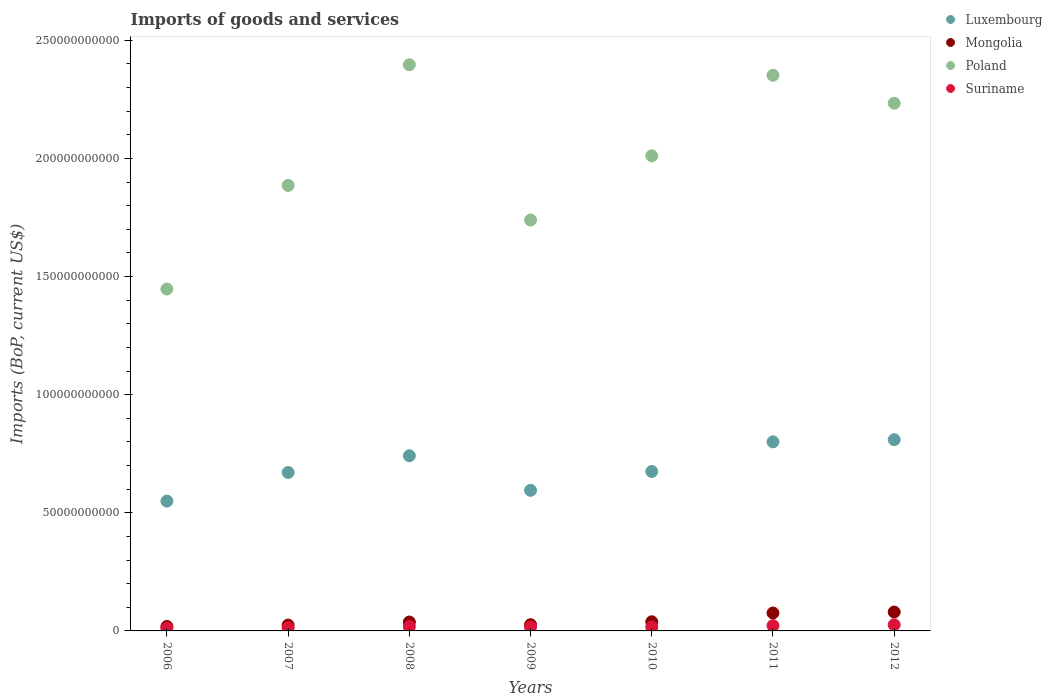What is the amount spent on imports in Suriname in 2008?
Your answer should be compact. 1.81e+09. Across all years, what is the maximum amount spent on imports in Mongolia?
Provide a succinct answer. 8.00e+09. Across all years, what is the minimum amount spent on imports in Mongolia?
Provide a succinct answer. 1.88e+09. In which year was the amount spent on imports in Suriname minimum?
Provide a short and direct response. 2006. What is the total amount spent on imports in Suriname in the graph?
Ensure brevity in your answer.  1.25e+1. What is the difference between the amount spent on imports in Poland in 2007 and that in 2010?
Provide a succinct answer. -1.25e+1. What is the difference between the amount spent on imports in Luxembourg in 2006 and the amount spent on imports in Suriname in 2012?
Provide a succinct answer. 5.24e+1. What is the average amount spent on imports in Poland per year?
Offer a very short reply. 2.01e+11. In the year 2007, what is the difference between the amount spent on imports in Suriname and amount spent on imports in Mongolia?
Your answer should be very brief. -1.11e+09. What is the ratio of the amount spent on imports in Suriname in 2007 to that in 2011?
Give a very brief answer. 0.61. What is the difference between the highest and the second highest amount spent on imports in Suriname?
Provide a short and direct response. 3.42e+08. What is the difference between the highest and the lowest amount spent on imports in Suriname?
Provide a succinct answer. 1.41e+09. Does the amount spent on imports in Suriname monotonically increase over the years?
Provide a succinct answer. No. How many dotlines are there?
Make the answer very short. 4. What is the difference between two consecutive major ticks on the Y-axis?
Ensure brevity in your answer.  5.00e+1. Are the values on the major ticks of Y-axis written in scientific E-notation?
Offer a very short reply. No. Does the graph contain any zero values?
Offer a terse response. No. Does the graph contain grids?
Your answer should be very brief. No. Where does the legend appear in the graph?
Provide a succinct answer. Top right. How are the legend labels stacked?
Provide a succinct answer. Vertical. What is the title of the graph?
Your answer should be compact. Imports of goods and services. Does "Zambia" appear as one of the legend labels in the graph?
Make the answer very short. No. What is the label or title of the X-axis?
Ensure brevity in your answer.  Years. What is the label or title of the Y-axis?
Provide a succinct answer. Imports (BoP, current US$). What is the Imports (BoP, current US$) of Luxembourg in 2006?
Ensure brevity in your answer.  5.49e+1. What is the Imports (BoP, current US$) of Mongolia in 2006?
Make the answer very short. 1.88e+09. What is the Imports (BoP, current US$) of Poland in 2006?
Your answer should be compact. 1.45e+11. What is the Imports (BoP, current US$) in Suriname in 2006?
Keep it short and to the point. 1.17e+09. What is the Imports (BoP, current US$) in Luxembourg in 2007?
Provide a short and direct response. 6.71e+1. What is the Imports (BoP, current US$) of Mongolia in 2007?
Provide a succinct answer. 2.48e+09. What is the Imports (BoP, current US$) of Poland in 2007?
Your response must be concise. 1.89e+11. What is the Imports (BoP, current US$) in Suriname in 2007?
Ensure brevity in your answer.  1.36e+09. What is the Imports (BoP, current US$) in Luxembourg in 2008?
Your response must be concise. 7.41e+1. What is the Imports (BoP, current US$) of Mongolia in 2008?
Ensure brevity in your answer.  3.77e+09. What is the Imports (BoP, current US$) of Poland in 2008?
Offer a very short reply. 2.40e+11. What is the Imports (BoP, current US$) in Suriname in 2008?
Provide a short and direct response. 1.81e+09. What is the Imports (BoP, current US$) of Luxembourg in 2009?
Your answer should be compact. 5.95e+1. What is the Imports (BoP, current US$) in Mongolia in 2009?
Your response must be concise. 2.63e+09. What is the Imports (BoP, current US$) of Poland in 2009?
Ensure brevity in your answer.  1.74e+11. What is the Imports (BoP, current US$) of Suriname in 2009?
Provide a succinct answer. 1.68e+09. What is the Imports (BoP, current US$) in Luxembourg in 2010?
Keep it short and to the point. 6.75e+1. What is the Imports (BoP, current US$) of Mongolia in 2010?
Keep it short and to the point. 3.87e+09. What is the Imports (BoP, current US$) in Poland in 2010?
Ensure brevity in your answer.  2.01e+11. What is the Imports (BoP, current US$) in Suriname in 2010?
Your answer should be very brief. 1.66e+09. What is the Imports (BoP, current US$) in Luxembourg in 2011?
Your response must be concise. 8.00e+1. What is the Imports (BoP, current US$) in Mongolia in 2011?
Offer a very short reply. 7.59e+09. What is the Imports (BoP, current US$) in Poland in 2011?
Keep it short and to the point. 2.35e+11. What is the Imports (BoP, current US$) in Suriname in 2011?
Make the answer very short. 2.24e+09. What is the Imports (BoP, current US$) of Luxembourg in 2012?
Provide a succinct answer. 8.09e+1. What is the Imports (BoP, current US$) of Mongolia in 2012?
Your response must be concise. 8.00e+09. What is the Imports (BoP, current US$) in Poland in 2012?
Offer a very short reply. 2.23e+11. What is the Imports (BoP, current US$) in Suriname in 2012?
Offer a very short reply. 2.58e+09. Across all years, what is the maximum Imports (BoP, current US$) in Luxembourg?
Your response must be concise. 8.09e+1. Across all years, what is the maximum Imports (BoP, current US$) in Mongolia?
Give a very brief answer. 8.00e+09. Across all years, what is the maximum Imports (BoP, current US$) in Poland?
Provide a succinct answer. 2.40e+11. Across all years, what is the maximum Imports (BoP, current US$) in Suriname?
Give a very brief answer. 2.58e+09. Across all years, what is the minimum Imports (BoP, current US$) of Luxembourg?
Your answer should be very brief. 5.49e+1. Across all years, what is the minimum Imports (BoP, current US$) of Mongolia?
Your response must be concise. 1.88e+09. Across all years, what is the minimum Imports (BoP, current US$) of Poland?
Offer a terse response. 1.45e+11. Across all years, what is the minimum Imports (BoP, current US$) of Suriname?
Provide a succinct answer. 1.17e+09. What is the total Imports (BoP, current US$) of Luxembourg in the graph?
Offer a terse response. 4.84e+11. What is the total Imports (BoP, current US$) in Mongolia in the graph?
Ensure brevity in your answer.  3.02e+1. What is the total Imports (BoP, current US$) in Poland in the graph?
Make the answer very short. 1.41e+12. What is the total Imports (BoP, current US$) of Suriname in the graph?
Offer a terse response. 1.25e+1. What is the difference between the Imports (BoP, current US$) in Luxembourg in 2006 and that in 2007?
Offer a terse response. -1.21e+1. What is the difference between the Imports (BoP, current US$) of Mongolia in 2006 and that in 2007?
Give a very brief answer. -5.96e+08. What is the difference between the Imports (BoP, current US$) of Poland in 2006 and that in 2007?
Provide a succinct answer. -4.39e+1. What is the difference between the Imports (BoP, current US$) in Suriname in 2006 and that in 2007?
Provide a succinct answer. -1.91e+08. What is the difference between the Imports (BoP, current US$) in Luxembourg in 2006 and that in 2008?
Ensure brevity in your answer.  -1.92e+1. What is the difference between the Imports (BoP, current US$) of Mongolia in 2006 and that in 2008?
Offer a terse response. -1.89e+09. What is the difference between the Imports (BoP, current US$) in Poland in 2006 and that in 2008?
Offer a very short reply. -9.49e+1. What is the difference between the Imports (BoP, current US$) of Suriname in 2006 and that in 2008?
Offer a very short reply. -6.42e+08. What is the difference between the Imports (BoP, current US$) of Luxembourg in 2006 and that in 2009?
Ensure brevity in your answer.  -4.56e+09. What is the difference between the Imports (BoP, current US$) of Mongolia in 2006 and that in 2009?
Keep it short and to the point. -7.50e+08. What is the difference between the Imports (BoP, current US$) of Poland in 2006 and that in 2009?
Offer a terse response. -2.92e+1. What is the difference between the Imports (BoP, current US$) in Suriname in 2006 and that in 2009?
Your response must be concise. -5.04e+08. What is the difference between the Imports (BoP, current US$) of Luxembourg in 2006 and that in 2010?
Your answer should be very brief. -1.25e+1. What is the difference between the Imports (BoP, current US$) of Mongolia in 2006 and that in 2010?
Offer a terse response. -1.99e+09. What is the difference between the Imports (BoP, current US$) in Poland in 2006 and that in 2010?
Offer a very short reply. -5.64e+1. What is the difference between the Imports (BoP, current US$) in Suriname in 2006 and that in 2010?
Provide a short and direct response. -4.85e+08. What is the difference between the Imports (BoP, current US$) of Luxembourg in 2006 and that in 2011?
Keep it short and to the point. -2.51e+1. What is the difference between the Imports (BoP, current US$) in Mongolia in 2006 and that in 2011?
Keep it short and to the point. -5.71e+09. What is the difference between the Imports (BoP, current US$) in Poland in 2006 and that in 2011?
Provide a short and direct response. -9.05e+1. What is the difference between the Imports (BoP, current US$) of Suriname in 2006 and that in 2011?
Your answer should be compact. -1.07e+09. What is the difference between the Imports (BoP, current US$) in Luxembourg in 2006 and that in 2012?
Offer a terse response. -2.60e+1. What is the difference between the Imports (BoP, current US$) of Mongolia in 2006 and that in 2012?
Provide a succinct answer. -6.12e+09. What is the difference between the Imports (BoP, current US$) in Poland in 2006 and that in 2012?
Offer a terse response. -7.87e+1. What is the difference between the Imports (BoP, current US$) in Suriname in 2006 and that in 2012?
Your answer should be compact. -1.41e+09. What is the difference between the Imports (BoP, current US$) of Luxembourg in 2007 and that in 2008?
Provide a succinct answer. -7.06e+09. What is the difference between the Imports (BoP, current US$) in Mongolia in 2007 and that in 2008?
Make the answer very short. -1.29e+09. What is the difference between the Imports (BoP, current US$) of Poland in 2007 and that in 2008?
Offer a very short reply. -5.11e+1. What is the difference between the Imports (BoP, current US$) of Suriname in 2007 and that in 2008?
Ensure brevity in your answer.  -4.51e+08. What is the difference between the Imports (BoP, current US$) in Luxembourg in 2007 and that in 2009?
Offer a very short reply. 7.57e+09. What is the difference between the Imports (BoP, current US$) of Mongolia in 2007 and that in 2009?
Your answer should be compact. -1.55e+08. What is the difference between the Imports (BoP, current US$) in Poland in 2007 and that in 2009?
Provide a short and direct response. 1.47e+1. What is the difference between the Imports (BoP, current US$) in Suriname in 2007 and that in 2009?
Give a very brief answer. -3.13e+08. What is the difference between the Imports (BoP, current US$) in Luxembourg in 2007 and that in 2010?
Offer a very short reply. -4.05e+08. What is the difference between the Imports (BoP, current US$) of Mongolia in 2007 and that in 2010?
Your response must be concise. -1.39e+09. What is the difference between the Imports (BoP, current US$) in Poland in 2007 and that in 2010?
Provide a short and direct response. -1.25e+1. What is the difference between the Imports (BoP, current US$) of Suriname in 2007 and that in 2010?
Your response must be concise. -2.94e+08. What is the difference between the Imports (BoP, current US$) in Luxembourg in 2007 and that in 2011?
Give a very brief answer. -1.29e+1. What is the difference between the Imports (BoP, current US$) of Mongolia in 2007 and that in 2011?
Keep it short and to the point. -5.12e+09. What is the difference between the Imports (BoP, current US$) of Poland in 2007 and that in 2011?
Ensure brevity in your answer.  -4.66e+1. What is the difference between the Imports (BoP, current US$) of Suriname in 2007 and that in 2011?
Your response must be concise. -8.79e+08. What is the difference between the Imports (BoP, current US$) in Luxembourg in 2007 and that in 2012?
Your answer should be compact. -1.39e+1. What is the difference between the Imports (BoP, current US$) of Mongolia in 2007 and that in 2012?
Keep it short and to the point. -5.52e+09. What is the difference between the Imports (BoP, current US$) in Poland in 2007 and that in 2012?
Offer a terse response. -3.48e+1. What is the difference between the Imports (BoP, current US$) of Suriname in 2007 and that in 2012?
Offer a terse response. -1.22e+09. What is the difference between the Imports (BoP, current US$) in Luxembourg in 2008 and that in 2009?
Offer a terse response. 1.46e+1. What is the difference between the Imports (BoP, current US$) in Mongolia in 2008 and that in 2009?
Keep it short and to the point. 1.14e+09. What is the difference between the Imports (BoP, current US$) in Poland in 2008 and that in 2009?
Keep it short and to the point. 6.57e+1. What is the difference between the Imports (BoP, current US$) of Suriname in 2008 and that in 2009?
Offer a terse response. 1.38e+08. What is the difference between the Imports (BoP, current US$) of Luxembourg in 2008 and that in 2010?
Provide a succinct answer. 6.66e+09. What is the difference between the Imports (BoP, current US$) of Mongolia in 2008 and that in 2010?
Offer a very short reply. -1.02e+08. What is the difference between the Imports (BoP, current US$) of Poland in 2008 and that in 2010?
Offer a very short reply. 3.85e+1. What is the difference between the Imports (BoP, current US$) in Suriname in 2008 and that in 2010?
Keep it short and to the point. 1.57e+08. What is the difference between the Imports (BoP, current US$) of Luxembourg in 2008 and that in 2011?
Your answer should be compact. -5.89e+09. What is the difference between the Imports (BoP, current US$) of Mongolia in 2008 and that in 2011?
Provide a succinct answer. -3.82e+09. What is the difference between the Imports (BoP, current US$) in Poland in 2008 and that in 2011?
Offer a very short reply. 4.46e+09. What is the difference between the Imports (BoP, current US$) of Suriname in 2008 and that in 2011?
Offer a very short reply. -4.28e+08. What is the difference between the Imports (BoP, current US$) of Luxembourg in 2008 and that in 2012?
Your answer should be compact. -6.82e+09. What is the difference between the Imports (BoP, current US$) in Mongolia in 2008 and that in 2012?
Give a very brief answer. -4.23e+09. What is the difference between the Imports (BoP, current US$) of Poland in 2008 and that in 2012?
Offer a very short reply. 1.63e+1. What is the difference between the Imports (BoP, current US$) of Suriname in 2008 and that in 2012?
Keep it short and to the point. -7.70e+08. What is the difference between the Imports (BoP, current US$) in Luxembourg in 2009 and that in 2010?
Your answer should be very brief. -7.98e+09. What is the difference between the Imports (BoP, current US$) of Mongolia in 2009 and that in 2010?
Provide a succinct answer. -1.24e+09. What is the difference between the Imports (BoP, current US$) of Poland in 2009 and that in 2010?
Give a very brief answer. -2.72e+1. What is the difference between the Imports (BoP, current US$) of Suriname in 2009 and that in 2010?
Provide a short and direct response. 1.91e+07. What is the difference between the Imports (BoP, current US$) in Luxembourg in 2009 and that in 2011?
Offer a very short reply. -2.05e+1. What is the difference between the Imports (BoP, current US$) of Mongolia in 2009 and that in 2011?
Provide a succinct answer. -4.96e+09. What is the difference between the Imports (BoP, current US$) in Poland in 2009 and that in 2011?
Offer a very short reply. -6.13e+1. What is the difference between the Imports (BoP, current US$) of Suriname in 2009 and that in 2011?
Your answer should be compact. -5.66e+08. What is the difference between the Imports (BoP, current US$) of Luxembourg in 2009 and that in 2012?
Offer a terse response. -2.14e+1. What is the difference between the Imports (BoP, current US$) of Mongolia in 2009 and that in 2012?
Provide a succinct answer. -5.37e+09. What is the difference between the Imports (BoP, current US$) of Poland in 2009 and that in 2012?
Offer a terse response. -4.95e+1. What is the difference between the Imports (BoP, current US$) of Suriname in 2009 and that in 2012?
Your response must be concise. -9.08e+08. What is the difference between the Imports (BoP, current US$) in Luxembourg in 2010 and that in 2011?
Your answer should be compact. -1.25e+1. What is the difference between the Imports (BoP, current US$) of Mongolia in 2010 and that in 2011?
Your answer should be compact. -3.72e+09. What is the difference between the Imports (BoP, current US$) in Poland in 2010 and that in 2011?
Ensure brevity in your answer.  -3.41e+1. What is the difference between the Imports (BoP, current US$) in Suriname in 2010 and that in 2011?
Keep it short and to the point. -5.85e+08. What is the difference between the Imports (BoP, current US$) in Luxembourg in 2010 and that in 2012?
Give a very brief answer. -1.35e+1. What is the difference between the Imports (BoP, current US$) in Mongolia in 2010 and that in 2012?
Give a very brief answer. -4.13e+09. What is the difference between the Imports (BoP, current US$) of Poland in 2010 and that in 2012?
Your response must be concise. -2.23e+1. What is the difference between the Imports (BoP, current US$) of Suriname in 2010 and that in 2012?
Ensure brevity in your answer.  -9.27e+08. What is the difference between the Imports (BoP, current US$) in Luxembourg in 2011 and that in 2012?
Provide a short and direct response. -9.28e+08. What is the difference between the Imports (BoP, current US$) of Mongolia in 2011 and that in 2012?
Your answer should be compact. -4.07e+08. What is the difference between the Imports (BoP, current US$) of Poland in 2011 and that in 2012?
Your response must be concise. 1.18e+1. What is the difference between the Imports (BoP, current US$) of Suriname in 2011 and that in 2012?
Your answer should be very brief. -3.42e+08. What is the difference between the Imports (BoP, current US$) in Luxembourg in 2006 and the Imports (BoP, current US$) in Mongolia in 2007?
Offer a very short reply. 5.25e+1. What is the difference between the Imports (BoP, current US$) of Luxembourg in 2006 and the Imports (BoP, current US$) of Poland in 2007?
Offer a terse response. -1.34e+11. What is the difference between the Imports (BoP, current US$) in Luxembourg in 2006 and the Imports (BoP, current US$) in Suriname in 2007?
Offer a very short reply. 5.36e+1. What is the difference between the Imports (BoP, current US$) in Mongolia in 2006 and the Imports (BoP, current US$) in Poland in 2007?
Give a very brief answer. -1.87e+11. What is the difference between the Imports (BoP, current US$) in Mongolia in 2006 and the Imports (BoP, current US$) in Suriname in 2007?
Your answer should be compact. 5.17e+08. What is the difference between the Imports (BoP, current US$) in Poland in 2006 and the Imports (BoP, current US$) in Suriname in 2007?
Your answer should be very brief. 1.43e+11. What is the difference between the Imports (BoP, current US$) in Luxembourg in 2006 and the Imports (BoP, current US$) in Mongolia in 2008?
Offer a very short reply. 5.12e+1. What is the difference between the Imports (BoP, current US$) in Luxembourg in 2006 and the Imports (BoP, current US$) in Poland in 2008?
Provide a short and direct response. -1.85e+11. What is the difference between the Imports (BoP, current US$) of Luxembourg in 2006 and the Imports (BoP, current US$) of Suriname in 2008?
Make the answer very short. 5.31e+1. What is the difference between the Imports (BoP, current US$) of Mongolia in 2006 and the Imports (BoP, current US$) of Poland in 2008?
Your answer should be very brief. -2.38e+11. What is the difference between the Imports (BoP, current US$) in Mongolia in 2006 and the Imports (BoP, current US$) in Suriname in 2008?
Provide a short and direct response. 6.60e+07. What is the difference between the Imports (BoP, current US$) of Poland in 2006 and the Imports (BoP, current US$) of Suriname in 2008?
Provide a succinct answer. 1.43e+11. What is the difference between the Imports (BoP, current US$) in Luxembourg in 2006 and the Imports (BoP, current US$) in Mongolia in 2009?
Offer a terse response. 5.23e+1. What is the difference between the Imports (BoP, current US$) in Luxembourg in 2006 and the Imports (BoP, current US$) in Poland in 2009?
Offer a very short reply. -1.19e+11. What is the difference between the Imports (BoP, current US$) of Luxembourg in 2006 and the Imports (BoP, current US$) of Suriname in 2009?
Offer a terse response. 5.33e+1. What is the difference between the Imports (BoP, current US$) of Mongolia in 2006 and the Imports (BoP, current US$) of Poland in 2009?
Provide a succinct answer. -1.72e+11. What is the difference between the Imports (BoP, current US$) of Mongolia in 2006 and the Imports (BoP, current US$) of Suriname in 2009?
Give a very brief answer. 2.04e+08. What is the difference between the Imports (BoP, current US$) in Poland in 2006 and the Imports (BoP, current US$) in Suriname in 2009?
Your answer should be very brief. 1.43e+11. What is the difference between the Imports (BoP, current US$) in Luxembourg in 2006 and the Imports (BoP, current US$) in Mongolia in 2010?
Offer a very short reply. 5.11e+1. What is the difference between the Imports (BoP, current US$) in Luxembourg in 2006 and the Imports (BoP, current US$) in Poland in 2010?
Ensure brevity in your answer.  -1.46e+11. What is the difference between the Imports (BoP, current US$) of Luxembourg in 2006 and the Imports (BoP, current US$) of Suriname in 2010?
Your answer should be very brief. 5.33e+1. What is the difference between the Imports (BoP, current US$) in Mongolia in 2006 and the Imports (BoP, current US$) in Poland in 2010?
Ensure brevity in your answer.  -1.99e+11. What is the difference between the Imports (BoP, current US$) in Mongolia in 2006 and the Imports (BoP, current US$) in Suriname in 2010?
Your response must be concise. 2.23e+08. What is the difference between the Imports (BoP, current US$) of Poland in 2006 and the Imports (BoP, current US$) of Suriname in 2010?
Your answer should be very brief. 1.43e+11. What is the difference between the Imports (BoP, current US$) in Luxembourg in 2006 and the Imports (BoP, current US$) in Mongolia in 2011?
Offer a terse response. 4.74e+1. What is the difference between the Imports (BoP, current US$) of Luxembourg in 2006 and the Imports (BoP, current US$) of Poland in 2011?
Ensure brevity in your answer.  -1.80e+11. What is the difference between the Imports (BoP, current US$) in Luxembourg in 2006 and the Imports (BoP, current US$) in Suriname in 2011?
Provide a succinct answer. 5.27e+1. What is the difference between the Imports (BoP, current US$) of Mongolia in 2006 and the Imports (BoP, current US$) of Poland in 2011?
Give a very brief answer. -2.33e+11. What is the difference between the Imports (BoP, current US$) of Mongolia in 2006 and the Imports (BoP, current US$) of Suriname in 2011?
Ensure brevity in your answer.  -3.62e+08. What is the difference between the Imports (BoP, current US$) of Poland in 2006 and the Imports (BoP, current US$) of Suriname in 2011?
Your answer should be very brief. 1.42e+11. What is the difference between the Imports (BoP, current US$) in Luxembourg in 2006 and the Imports (BoP, current US$) in Mongolia in 2012?
Your answer should be compact. 4.69e+1. What is the difference between the Imports (BoP, current US$) in Luxembourg in 2006 and the Imports (BoP, current US$) in Poland in 2012?
Your response must be concise. -1.68e+11. What is the difference between the Imports (BoP, current US$) in Luxembourg in 2006 and the Imports (BoP, current US$) in Suriname in 2012?
Give a very brief answer. 5.24e+1. What is the difference between the Imports (BoP, current US$) of Mongolia in 2006 and the Imports (BoP, current US$) of Poland in 2012?
Your answer should be compact. -2.21e+11. What is the difference between the Imports (BoP, current US$) in Mongolia in 2006 and the Imports (BoP, current US$) in Suriname in 2012?
Give a very brief answer. -7.04e+08. What is the difference between the Imports (BoP, current US$) in Poland in 2006 and the Imports (BoP, current US$) in Suriname in 2012?
Offer a terse response. 1.42e+11. What is the difference between the Imports (BoP, current US$) of Luxembourg in 2007 and the Imports (BoP, current US$) of Mongolia in 2008?
Keep it short and to the point. 6.33e+1. What is the difference between the Imports (BoP, current US$) of Luxembourg in 2007 and the Imports (BoP, current US$) of Poland in 2008?
Make the answer very short. -1.73e+11. What is the difference between the Imports (BoP, current US$) of Luxembourg in 2007 and the Imports (BoP, current US$) of Suriname in 2008?
Your answer should be compact. 6.53e+1. What is the difference between the Imports (BoP, current US$) of Mongolia in 2007 and the Imports (BoP, current US$) of Poland in 2008?
Your answer should be compact. -2.37e+11. What is the difference between the Imports (BoP, current US$) of Mongolia in 2007 and the Imports (BoP, current US$) of Suriname in 2008?
Keep it short and to the point. 6.62e+08. What is the difference between the Imports (BoP, current US$) of Poland in 2007 and the Imports (BoP, current US$) of Suriname in 2008?
Keep it short and to the point. 1.87e+11. What is the difference between the Imports (BoP, current US$) in Luxembourg in 2007 and the Imports (BoP, current US$) in Mongolia in 2009?
Give a very brief answer. 6.44e+1. What is the difference between the Imports (BoP, current US$) in Luxembourg in 2007 and the Imports (BoP, current US$) in Poland in 2009?
Keep it short and to the point. -1.07e+11. What is the difference between the Imports (BoP, current US$) in Luxembourg in 2007 and the Imports (BoP, current US$) in Suriname in 2009?
Your answer should be compact. 6.54e+1. What is the difference between the Imports (BoP, current US$) of Mongolia in 2007 and the Imports (BoP, current US$) of Poland in 2009?
Your answer should be compact. -1.71e+11. What is the difference between the Imports (BoP, current US$) in Mongolia in 2007 and the Imports (BoP, current US$) in Suriname in 2009?
Offer a terse response. 8.00e+08. What is the difference between the Imports (BoP, current US$) of Poland in 2007 and the Imports (BoP, current US$) of Suriname in 2009?
Give a very brief answer. 1.87e+11. What is the difference between the Imports (BoP, current US$) of Luxembourg in 2007 and the Imports (BoP, current US$) of Mongolia in 2010?
Your answer should be compact. 6.32e+1. What is the difference between the Imports (BoP, current US$) in Luxembourg in 2007 and the Imports (BoP, current US$) in Poland in 2010?
Give a very brief answer. -1.34e+11. What is the difference between the Imports (BoP, current US$) in Luxembourg in 2007 and the Imports (BoP, current US$) in Suriname in 2010?
Provide a short and direct response. 6.54e+1. What is the difference between the Imports (BoP, current US$) in Mongolia in 2007 and the Imports (BoP, current US$) in Poland in 2010?
Offer a terse response. -1.99e+11. What is the difference between the Imports (BoP, current US$) of Mongolia in 2007 and the Imports (BoP, current US$) of Suriname in 2010?
Give a very brief answer. 8.19e+08. What is the difference between the Imports (BoP, current US$) in Poland in 2007 and the Imports (BoP, current US$) in Suriname in 2010?
Make the answer very short. 1.87e+11. What is the difference between the Imports (BoP, current US$) in Luxembourg in 2007 and the Imports (BoP, current US$) in Mongolia in 2011?
Make the answer very short. 5.95e+1. What is the difference between the Imports (BoP, current US$) of Luxembourg in 2007 and the Imports (BoP, current US$) of Poland in 2011?
Your answer should be compact. -1.68e+11. What is the difference between the Imports (BoP, current US$) in Luxembourg in 2007 and the Imports (BoP, current US$) in Suriname in 2011?
Make the answer very short. 6.48e+1. What is the difference between the Imports (BoP, current US$) in Mongolia in 2007 and the Imports (BoP, current US$) in Poland in 2011?
Provide a short and direct response. -2.33e+11. What is the difference between the Imports (BoP, current US$) in Mongolia in 2007 and the Imports (BoP, current US$) in Suriname in 2011?
Give a very brief answer. 2.34e+08. What is the difference between the Imports (BoP, current US$) in Poland in 2007 and the Imports (BoP, current US$) in Suriname in 2011?
Provide a succinct answer. 1.86e+11. What is the difference between the Imports (BoP, current US$) in Luxembourg in 2007 and the Imports (BoP, current US$) in Mongolia in 2012?
Give a very brief answer. 5.91e+1. What is the difference between the Imports (BoP, current US$) of Luxembourg in 2007 and the Imports (BoP, current US$) of Poland in 2012?
Your answer should be very brief. -1.56e+11. What is the difference between the Imports (BoP, current US$) of Luxembourg in 2007 and the Imports (BoP, current US$) of Suriname in 2012?
Offer a terse response. 6.45e+1. What is the difference between the Imports (BoP, current US$) of Mongolia in 2007 and the Imports (BoP, current US$) of Poland in 2012?
Your answer should be very brief. -2.21e+11. What is the difference between the Imports (BoP, current US$) in Mongolia in 2007 and the Imports (BoP, current US$) in Suriname in 2012?
Ensure brevity in your answer.  -1.08e+08. What is the difference between the Imports (BoP, current US$) in Poland in 2007 and the Imports (BoP, current US$) in Suriname in 2012?
Give a very brief answer. 1.86e+11. What is the difference between the Imports (BoP, current US$) in Luxembourg in 2008 and the Imports (BoP, current US$) in Mongolia in 2009?
Your answer should be compact. 7.15e+1. What is the difference between the Imports (BoP, current US$) of Luxembourg in 2008 and the Imports (BoP, current US$) of Poland in 2009?
Your answer should be compact. -9.98e+1. What is the difference between the Imports (BoP, current US$) in Luxembourg in 2008 and the Imports (BoP, current US$) in Suriname in 2009?
Provide a short and direct response. 7.25e+1. What is the difference between the Imports (BoP, current US$) of Mongolia in 2008 and the Imports (BoP, current US$) of Poland in 2009?
Provide a short and direct response. -1.70e+11. What is the difference between the Imports (BoP, current US$) of Mongolia in 2008 and the Imports (BoP, current US$) of Suriname in 2009?
Provide a succinct answer. 2.09e+09. What is the difference between the Imports (BoP, current US$) in Poland in 2008 and the Imports (BoP, current US$) in Suriname in 2009?
Make the answer very short. 2.38e+11. What is the difference between the Imports (BoP, current US$) of Luxembourg in 2008 and the Imports (BoP, current US$) of Mongolia in 2010?
Your answer should be very brief. 7.03e+1. What is the difference between the Imports (BoP, current US$) in Luxembourg in 2008 and the Imports (BoP, current US$) in Poland in 2010?
Make the answer very short. -1.27e+11. What is the difference between the Imports (BoP, current US$) in Luxembourg in 2008 and the Imports (BoP, current US$) in Suriname in 2010?
Your answer should be very brief. 7.25e+1. What is the difference between the Imports (BoP, current US$) of Mongolia in 2008 and the Imports (BoP, current US$) of Poland in 2010?
Provide a short and direct response. -1.97e+11. What is the difference between the Imports (BoP, current US$) of Mongolia in 2008 and the Imports (BoP, current US$) of Suriname in 2010?
Keep it short and to the point. 2.11e+09. What is the difference between the Imports (BoP, current US$) in Poland in 2008 and the Imports (BoP, current US$) in Suriname in 2010?
Your answer should be compact. 2.38e+11. What is the difference between the Imports (BoP, current US$) of Luxembourg in 2008 and the Imports (BoP, current US$) of Mongolia in 2011?
Give a very brief answer. 6.65e+1. What is the difference between the Imports (BoP, current US$) of Luxembourg in 2008 and the Imports (BoP, current US$) of Poland in 2011?
Provide a short and direct response. -1.61e+11. What is the difference between the Imports (BoP, current US$) of Luxembourg in 2008 and the Imports (BoP, current US$) of Suriname in 2011?
Provide a succinct answer. 7.19e+1. What is the difference between the Imports (BoP, current US$) of Mongolia in 2008 and the Imports (BoP, current US$) of Poland in 2011?
Your answer should be very brief. -2.31e+11. What is the difference between the Imports (BoP, current US$) in Mongolia in 2008 and the Imports (BoP, current US$) in Suriname in 2011?
Offer a very short reply. 1.52e+09. What is the difference between the Imports (BoP, current US$) of Poland in 2008 and the Imports (BoP, current US$) of Suriname in 2011?
Make the answer very short. 2.37e+11. What is the difference between the Imports (BoP, current US$) of Luxembourg in 2008 and the Imports (BoP, current US$) of Mongolia in 2012?
Keep it short and to the point. 6.61e+1. What is the difference between the Imports (BoP, current US$) in Luxembourg in 2008 and the Imports (BoP, current US$) in Poland in 2012?
Provide a succinct answer. -1.49e+11. What is the difference between the Imports (BoP, current US$) of Luxembourg in 2008 and the Imports (BoP, current US$) of Suriname in 2012?
Offer a terse response. 7.15e+1. What is the difference between the Imports (BoP, current US$) in Mongolia in 2008 and the Imports (BoP, current US$) in Poland in 2012?
Keep it short and to the point. -2.20e+11. What is the difference between the Imports (BoP, current US$) of Mongolia in 2008 and the Imports (BoP, current US$) of Suriname in 2012?
Ensure brevity in your answer.  1.18e+09. What is the difference between the Imports (BoP, current US$) in Poland in 2008 and the Imports (BoP, current US$) in Suriname in 2012?
Your answer should be very brief. 2.37e+11. What is the difference between the Imports (BoP, current US$) of Luxembourg in 2009 and the Imports (BoP, current US$) of Mongolia in 2010?
Provide a short and direct response. 5.56e+1. What is the difference between the Imports (BoP, current US$) in Luxembourg in 2009 and the Imports (BoP, current US$) in Poland in 2010?
Give a very brief answer. -1.42e+11. What is the difference between the Imports (BoP, current US$) in Luxembourg in 2009 and the Imports (BoP, current US$) in Suriname in 2010?
Your response must be concise. 5.78e+1. What is the difference between the Imports (BoP, current US$) in Mongolia in 2009 and the Imports (BoP, current US$) in Poland in 2010?
Give a very brief answer. -1.98e+11. What is the difference between the Imports (BoP, current US$) in Mongolia in 2009 and the Imports (BoP, current US$) in Suriname in 2010?
Offer a terse response. 9.73e+08. What is the difference between the Imports (BoP, current US$) in Poland in 2009 and the Imports (BoP, current US$) in Suriname in 2010?
Your answer should be very brief. 1.72e+11. What is the difference between the Imports (BoP, current US$) in Luxembourg in 2009 and the Imports (BoP, current US$) in Mongolia in 2011?
Provide a short and direct response. 5.19e+1. What is the difference between the Imports (BoP, current US$) of Luxembourg in 2009 and the Imports (BoP, current US$) of Poland in 2011?
Provide a succinct answer. -1.76e+11. What is the difference between the Imports (BoP, current US$) in Luxembourg in 2009 and the Imports (BoP, current US$) in Suriname in 2011?
Your answer should be very brief. 5.73e+1. What is the difference between the Imports (BoP, current US$) of Mongolia in 2009 and the Imports (BoP, current US$) of Poland in 2011?
Ensure brevity in your answer.  -2.33e+11. What is the difference between the Imports (BoP, current US$) of Mongolia in 2009 and the Imports (BoP, current US$) of Suriname in 2011?
Offer a very short reply. 3.89e+08. What is the difference between the Imports (BoP, current US$) of Poland in 2009 and the Imports (BoP, current US$) of Suriname in 2011?
Provide a succinct answer. 1.72e+11. What is the difference between the Imports (BoP, current US$) in Luxembourg in 2009 and the Imports (BoP, current US$) in Mongolia in 2012?
Provide a short and direct response. 5.15e+1. What is the difference between the Imports (BoP, current US$) in Luxembourg in 2009 and the Imports (BoP, current US$) in Poland in 2012?
Provide a short and direct response. -1.64e+11. What is the difference between the Imports (BoP, current US$) of Luxembourg in 2009 and the Imports (BoP, current US$) of Suriname in 2012?
Offer a terse response. 5.69e+1. What is the difference between the Imports (BoP, current US$) of Mongolia in 2009 and the Imports (BoP, current US$) of Poland in 2012?
Provide a succinct answer. -2.21e+11. What is the difference between the Imports (BoP, current US$) of Mongolia in 2009 and the Imports (BoP, current US$) of Suriname in 2012?
Offer a very short reply. 4.62e+07. What is the difference between the Imports (BoP, current US$) in Poland in 2009 and the Imports (BoP, current US$) in Suriname in 2012?
Your response must be concise. 1.71e+11. What is the difference between the Imports (BoP, current US$) of Luxembourg in 2010 and the Imports (BoP, current US$) of Mongolia in 2011?
Provide a succinct answer. 5.99e+1. What is the difference between the Imports (BoP, current US$) in Luxembourg in 2010 and the Imports (BoP, current US$) in Poland in 2011?
Offer a terse response. -1.68e+11. What is the difference between the Imports (BoP, current US$) of Luxembourg in 2010 and the Imports (BoP, current US$) of Suriname in 2011?
Your answer should be compact. 6.52e+1. What is the difference between the Imports (BoP, current US$) of Mongolia in 2010 and the Imports (BoP, current US$) of Poland in 2011?
Your response must be concise. -2.31e+11. What is the difference between the Imports (BoP, current US$) in Mongolia in 2010 and the Imports (BoP, current US$) in Suriname in 2011?
Offer a very short reply. 1.63e+09. What is the difference between the Imports (BoP, current US$) of Poland in 2010 and the Imports (BoP, current US$) of Suriname in 2011?
Provide a short and direct response. 1.99e+11. What is the difference between the Imports (BoP, current US$) in Luxembourg in 2010 and the Imports (BoP, current US$) in Mongolia in 2012?
Keep it short and to the point. 5.95e+1. What is the difference between the Imports (BoP, current US$) in Luxembourg in 2010 and the Imports (BoP, current US$) in Poland in 2012?
Your response must be concise. -1.56e+11. What is the difference between the Imports (BoP, current US$) of Luxembourg in 2010 and the Imports (BoP, current US$) of Suriname in 2012?
Offer a very short reply. 6.49e+1. What is the difference between the Imports (BoP, current US$) in Mongolia in 2010 and the Imports (BoP, current US$) in Poland in 2012?
Make the answer very short. -2.19e+11. What is the difference between the Imports (BoP, current US$) of Mongolia in 2010 and the Imports (BoP, current US$) of Suriname in 2012?
Provide a short and direct response. 1.28e+09. What is the difference between the Imports (BoP, current US$) of Poland in 2010 and the Imports (BoP, current US$) of Suriname in 2012?
Offer a terse response. 1.98e+11. What is the difference between the Imports (BoP, current US$) of Luxembourg in 2011 and the Imports (BoP, current US$) of Mongolia in 2012?
Keep it short and to the point. 7.20e+1. What is the difference between the Imports (BoP, current US$) of Luxembourg in 2011 and the Imports (BoP, current US$) of Poland in 2012?
Provide a short and direct response. -1.43e+11. What is the difference between the Imports (BoP, current US$) in Luxembourg in 2011 and the Imports (BoP, current US$) in Suriname in 2012?
Your answer should be compact. 7.74e+1. What is the difference between the Imports (BoP, current US$) in Mongolia in 2011 and the Imports (BoP, current US$) in Poland in 2012?
Keep it short and to the point. -2.16e+11. What is the difference between the Imports (BoP, current US$) in Mongolia in 2011 and the Imports (BoP, current US$) in Suriname in 2012?
Your response must be concise. 5.01e+09. What is the difference between the Imports (BoP, current US$) of Poland in 2011 and the Imports (BoP, current US$) of Suriname in 2012?
Provide a succinct answer. 2.33e+11. What is the average Imports (BoP, current US$) of Luxembourg per year?
Provide a short and direct response. 6.92e+1. What is the average Imports (BoP, current US$) of Mongolia per year?
Your answer should be very brief. 4.32e+09. What is the average Imports (BoP, current US$) in Poland per year?
Keep it short and to the point. 2.01e+11. What is the average Imports (BoP, current US$) in Suriname per year?
Make the answer very short. 1.79e+09. In the year 2006, what is the difference between the Imports (BoP, current US$) of Luxembourg and Imports (BoP, current US$) of Mongolia?
Provide a short and direct response. 5.31e+1. In the year 2006, what is the difference between the Imports (BoP, current US$) in Luxembourg and Imports (BoP, current US$) in Poland?
Make the answer very short. -8.98e+1. In the year 2006, what is the difference between the Imports (BoP, current US$) in Luxembourg and Imports (BoP, current US$) in Suriname?
Your answer should be very brief. 5.38e+1. In the year 2006, what is the difference between the Imports (BoP, current US$) in Mongolia and Imports (BoP, current US$) in Poland?
Your response must be concise. -1.43e+11. In the year 2006, what is the difference between the Imports (BoP, current US$) of Mongolia and Imports (BoP, current US$) of Suriname?
Provide a succinct answer. 7.08e+08. In the year 2006, what is the difference between the Imports (BoP, current US$) of Poland and Imports (BoP, current US$) of Suriname?
Keep it short and to the point. 1.44e+11. In the year 2007, what is the difference between the Imports (BoP, current US$) in Luxembourg and Imports (BoP, current US$) in Mongolia?
Offer a terse response. 6.46e+1. In the year 2007, what is the difference between the Imports (BoP, current US$) of Luxembourg and Imports (BoP, current US$) of Poland?
Offer a terse response. -1.21e+11. In the year 2007, what is the difference between the Imports (BoP, current US$) of Luxembourg and Imports (BoP, current US$) of Suriname?
Keep it short and to the point. 6.57e+1. In the year 2007, what is the difference between the Imports (BoP, current US$) in Mongolia and Imports (BoP, current US$) in Poland?
Keep it short and to the point. -1.86e+11. In the year 2007, what is the difference between the Imports (BoP, current US$) of Mongolia and Imports (BoP, current US$) of Suriname?
Offer a terse response. 1.11e+09. In the year 2007, what is the difference between the Imports (BoP, current US$) of Poland and Imports (BoP, current US$) of Suriname?
Offer a terse response. 1.87e+11. In the year 2008, what is the difference between the Imports (BoP, current US$) of Luxembourg and Imports (BoP, current US$) of Mongolia?
Offer a terse response. 7.04e+1. In the year 2008, what is the difference between the Imports (BoP, current US$) of Luxembourg and Imports (BoP, current US$) of Poland?
Provide a short and direct response. -1.65e+11. In the year 2008, what is the difference between the Imports (BoP, current US$) in Luxembourg and Imports (BoP, current US$) in Suriname?
Your answer should be compact. 7.23e+1. In the year 2008, what is the difference between the Imports (BoP, current US$) of Mongolia and Imports (BoP, current US$) of Poland?
Your answer should be very brief. -2.36e+11. In the year 2008, what is the difference between the Imports (BoP, current US$) of Mongolia and Imports (BoP, current US$) of Suriname?
Offer a very short reply. 1.95e+09. In the year 2008, what is the difference between the Imports (BoP, current US$) of Poland and Imports (BoP, current US$) of Suriname?
Make the answer very short. 2.38e+11. In the year 2009, what is the difference between the Imports (BoP, current US$) in Luxembourg and Imports (BoP, current US$) in Mongolia?
Your response must be concise. 5.69e+1. In the year 2009, what is the difference between the Imports (BoP, current US$) in Luxembourg and Imports (BoP, current US$) in Poland?
Provide a short and direct response. -1.14e+11. In the year 2009, what is the difference between the Imports (BoP, current US$) of Luxembourg and Imports (BoP, current US$) of Suriname?
Your answer should be very brief. 5.78e+1. In the year 2009, what is the difference between the Imports (BoP, current US$) in Mongolia and Imports (BoP, current US$) in Poland?
Give a very brief answer. -1.71e+11. In the year 2009, what is the difference between the Imports (BoP, current US$) in Mongolia and Imports (BoP, current US$) in Suriname?
Ensure brevity in your answer.  9.54e+08. In the year 2009, what is the difference between the Imports (BoP, current US$) in Poland and Imports (BoP, current US$) in Suriname?
Give a very brief answer. 1.72e+11. In the year 2010, what is the difference between the Imports (BoP, current US$) of Luxembourg and Imports (BoP, current US$) of Mongolia?
Offer a very short reply. 6.36e+1. In the year 2010, what is the difference between the Imports (BoP, current US$) in Luxembourg and Imports (BoP, current US$) in Poland?
Keep it short and to the point. -1.34e+11. In the year 2010, what is the difference between the Imports (BoP, current US$) of Luxembourg and Imports (BoP, current US$) of Suriname?
Make the answer very short. 6.58e+1. In the year 2010, what is the difference between the Imports (BoP, current US$) in Mongolia and Imports (BoP, current US$) in Poland?
Give a very brief answer. -1.97e+11. In the year 2010, what is the difference between the Imports (BoP, current US$) in Mongolia and Imports (BoP, current US$) in Suriname?
Make the answer very short. 2.21e+09. In the year 2010, what is the difference between the Imports (BoP, current US$) in Poland and Imports (BoP, current US$) in Suriname?
Your response must be concise. 1.99e+11. In the year 2011, what is the difference between the Imports (BoP, current US$) of Luxembourg and Imports (BoP, current US$) of Mongolia?
Offer a very short reply. 7.24e+1. In the year 2011, what is the difference between the Imports (BoP, current US$) of Luxembourg and Imports (BoP, current US$) of Poland?
Keep it short and to the point. -1.55e+11. In the year 2011, what is the difference between the Imports (BoP, current US$) in Luxembourg and Imports (BoP, current US$) in Suriname?
Your answer should be very brief. 7.78e+1. In the year 2011, what is the difference between the Imports (BoP, current US$) of Mongolia and Imports (BoP, current US$) of Poland?
Your response must be concise. -2.28e+11. In the year 2011, what is the difference between the Imports (BoP, current US$) of Mongolia and Imports (BoP, current US$) of Suriname?
Keep it short and to the point. 5.35e+09. In the year 2011, what is the difference between the Imports (BoP, current US$) in Poland and Imports (BoP, current US$) in Suriname?
Your answer should be compact. 2.33e+11. In the year 2012, what is the difference between the Imports (BoP, current US$) in Luxembourg and Imports (BoP, current US$) in Mongolia?
Keep it short and to the point. 7.30e+1. In the year 2012, what is the difference between the Imports (BoP, current US$) in Luxembourg and Imports (BoP, current US$) in Poland?
Your response must be concise. -1.42e+11. In the year 2012, what is the difference between the Imports (BoP, current US$) in Luxembourg and Imports (BoP, current US$) in Suriname?
Ensure brevity in your answer.  7.84e+1. In the year 2012, what is the difference between the Imports (BoP, current US$) in Mongolia and Imports (BoP, current US$) in Poland?
Make the answer very short. -2.15e+11. In the year 2012, what is the difference between the Imports (BoP, current US$) in Mongolia and Imports (BoP, current US$) in Suriname?
Your response must be concise. 5.41e+09. In the year 2012, what is the difference between the Imports (BoP, current US$) in Poland and Imports (BoP, current US$) in Suriname?
Ensure brevity in your answer.  2.21e+11. What is the ratio of the Imports (BoP, current US$) of Luxembourg in 2006 to that in 2007?
Provide a short and direct response. 0.82. What is the ratio of the Imports (BoP, current US$) in Mongolia in 2006 to that in 2007?
Give a very brief answer. 0.76. What is the ratio of the Imports (BoP, current US$) of Poland in 2006 to that in 2007?
Offer a very short reply. 0.77. What is the ratio of the Imports (BoP, current US$) in Suriname in 2006 to that in 2007?
Your answer should be compact. 0.86. What is the ratio of the Imports (BoP, current US$) of Luxembourg in 2006 to that in 2008?
Provide a short and direct response. 0.74. What is the ratio of the Imports (BoP, current US$) of Mongolia in 2006 to that in 2008?
Your answer should be compact. 0.5. What is the ratio of the Imports (BoP, current US$) of Poland in 2006 to that in 2008?
Make the answer very short. 0.6. What is the ratio of the Imports (BoP, current US$) in Suriname in 2006 to that in 2008?
Your response must be concise. 0.65. What is the ratio of the Imports (BoP, current US$) in Luxembourg in 2006 to that in 2009?
Provide a succinct answer. 0.92. What is the ratio of the Imports (BoP, current US$) of Mongolia in 2006 to that in 2009?
Your answer should be very brief. 0.71. What is the ratio of the Imports (BoP, current US$) in Poland in 2006 to that in 2009?
Provide a short and direct response. 0.83. What is the ratio of the Imports (BoP, current US$) of Suriname in 2006 to that in 2009?
Your answer should be compact. 0.7. What is the ratio of the Imports (BoP, current US$) in Luxembourg in 2006 to that in 2010?
Give a very brief answer. 0.81. What is the ratio of the Imports (BoP, current US$) in Mongolia in 2006 to that in 2010?
Offer a terse response. 0.49. What is the ratio of the Imports (BoP, current US$) of Poland in 2006 to that in 2010?
Make the answer very short. 0.72. What is the ratio of the Imports (BoP, current US$) in Suriname in 2006 to that in 2010?
Ensure brevity in your answer.  0.71. What is the ratio of the Imports (BoP, current US$) of Luxembourg in 2006 to that in 2011?
Your answer should be compact. 0.69. What is the ratio of the Imports (BoP, current US$) in Mongolia in 2006 to that in 2011?
Give a very brief answer. 0.25. What is the ratio of the Imports (BoP, current US$) of Poland in 2006 to that in 2011?
Your answer should be compact. 0.62. What is the ratio of the Imports (BoP, current US$) in Suriname in 2006 to that in 2011?
Your response must be concise. 0.52. What is the ratio of the Imports (BoP, current US$) in Luxembourg in 2006 to that in 2012?
Ensure brevity in your answer.  0.68. What is the ratio of the Imports (BoP, current US$) of Mongolia in 2006 to that in 2012?
Give a very brief answer. 0.23. What is the ratio of the Imports (BoP, current US$) of Poland in 2006 to that in 2012?
Offer a very short reply. 0.65. What is the ratio of the Imports (BoP, current US$) of Suriname in 2006 to that in 2012?
Provide a short and direct response. 0.45. What is the ratio of the Imports (BoP, current US$) in Luxembourg in 2007 to that in 2008?
Give a very brief answer. 0.9. What is the ratio of the Imports (BoP, current US$) in Mongolia in 2007 to that in 2008?
Ensure brevity in your answer.  0.66. What is the ratio of the Imports (BoP, current US$) of Poland in 2007 to that in 2008?
Provide a short and direct response. 0.79. What is the ratio of the Imports (BoP, current US$) of Suriname in 2007 to that in 2008?
Keep it short and to the point. 0.75. What is the ratio of the Imports (BoP, current US$) in Luxembourg in 2007 to that in 2009?
Provide a succinct answer. 1.13. What is the ratio of the Imports (BoP, current US$) of Poland in 2007 to that in 2009?
Keep it short and to the point. 1.08. What is the ratio of the Imports (BoP, current US$) of Suriname in 2007 to that in 2009?
Provide a succinct answer. 0.81. What is the ratio of the Imports (BoP, current US$) in Mongolia in 2007 to that in 2010?
Offer a very short reply. 0.64. What is the ratio of the Imports (BoP, current US$) in Poland in 2007 to that in 2010?
Your answer should be compact. 0.94. What is the ratio of the Imports (BoP, current US$) in Suriname in 2007 to that in 2010?
Provide a succinct answer. 0.82. What is the ratio of the Imports (BoP, current US$) in Luxembourg in 2007 to that in 2011?
Ensure brevity in your answer.  0.84. What is the ratio of the Imports (BoP, current US$) in Mongolia in 2007 to that in 2011?
Provide a succinct answer. 0.33. What is the ratio of the Imports (BoP, current US$) in Poland in 2007 to that in 2011?
Your answer should be very brief. 0.8. What is the ratio of the Imports (BoP, current US$) of Suriname in 2007 to that in 2011?
Your answer should be compact. 0.61. What is the ratio of the Imports (BoP, current US$) in Luxembourg in 2007 to that in 2012?
Make the answer very short. 0.83. What is the ratio of the Imports (BoP, current US$) of Mongolia in 2007 to that in 2012?
Keep it short and to the point. 0.31. What is the ratio of the Imports (BoP, current US$) in Poland in 2007 to that in 2012?
Offer a terse response. 0.84. What is the ratio of the Imports (BoP, current US$) in Suriname in 2007 to that in 2012?
Keep it short and to the point. 0.53. What is the ratio of the Imports (BoP, current US$) in Luxembourg in 2008 to that in 2009?
Your response must be concise. 1.25. What is the ratio of the Imports (BoP, current US$) of Mongolia in 2008 to that in 2009?
Provide a succinct answer. 1.43. What is the ratio of the Imports (BoP, current US$) of Poland in 2008 to that in 2009?
Make the answer very short. 1.38. What is the ratio of the Imports (BoP, current US$) of Suriname in 2008 to that in 2009?
Give a very brief answer. 1.08. What is the ratio of the Imports (BoP, current US$) of Luxembourg in 2008 to that in 2010?
Keep it short and to the point. 1.1. What is the ratio of the Imports (BoP, current US$) of Mongolia in 2008 to that in 2010?
Offer a terse response. 0.97. What is the ratio of the Imports (BoP, current US$) of Poland in 2008 to that in 2010?
Keep it short and to the point. 1.19. What is the ratio of the Imports (BoP, current US$) of Suriname in 2008 to that in 2010?
Ensure brevity in your answer.  1.09. What is the ratio of the Imports (BoP, current US$) in Luxembourg in 2008 to that in 2011?
Keep it short and to the point. 0.93. What is the ratio of the Imports (BoP, current US$) in Mongolia in 2008 to that in 2011?
Offer a very short reply. 0.5. What is the ratio of the Imports (BoP, current US$) of Suriname in 2008 to that in 2011?
Offer a very short reply. 0.81. What is the ratio of the Imports (BoP, current US$) in Luxembourg in 2008 to that in 2012?
Your response must be concise. 0.92. What is the ratio of the Imports (BoP, current US$) in Mongolia in 2008 to that in 2012?
Your answer should be compact. 0.47. What is the ratio of the Imports (BoP, current US$) in Poland in 2008 to that in 2012?
Offer a very short reply. 1.07. What is the ratio of the Imports (BoP, current US$) of Suriname in 2008 to that in 2012?
Your response must be concise. 0.7. What is the ratio of the Imports (BoP, current US$) of Luxembourg in 2009 to that in 2010?
Your answer should be compact. 0.88. What is the ratio of the Imports (BoP, current US$) in Mongolia in 2009 to that in 2010?
Provide a short and direct response. 0.68. What is the ratio of the Imports (BoP, current US$) in Poland in 2009 to that in 2010?
Your response must be concise. 0.86. What is the ratio of the Imports (BoP, current US$) of Suriname in 2009 to that in 2010?
Keep it short and to the point. 1.01. What is the ratio of the Imports (BoP, current US$) in Luxembourg in 2009 to that in 2011?
Keep it short and to the point. 0.74. What is the ratio of the Imports (BoP, current US$) in Mongolia in 2009 to that in 2011?
Provide a succinct answer. 0.35. What is the ratio of the Imports (BoP, current US$) of Poland in 2009 to that in 2011?
Give a very brief answer. 0.74. What is the ratio of the Imports (BoP, current US$) of Suriname in 2009 to that in 2011?
Ensure brevity in your answer.  0.75. What is the ratio of the Imports (BoP, current US$) of Luxembourg in 2009 to that in 2012?
Give a very brief answer. 0.73. What is the ratio of the Imports (BoP, current US$) in Mongolia in 2009 to that in 2012?
Offer a terse response. 0.33. What is the ratio of the Imports (BoP, current US$) in Poland in 2009 to that in 2012?
Ensure brevity in your answer.  0.78. What is the ratio of the Imports (BoP, current US$) of Suriname in 2009 to that in 2012?
Make the answer very short. 0.65. What is the ratio of the Imports (BoP, current US$) in Luxembourg in 2010 to that in 2011?
Offer a very short reply. 0.84. What is the ratio of the Imports (BoP, current US$) in Mongolia in 2010 to that in 2011?
Provide a succinct answer. 0.51. What is the ratio of the Imports (BoP, current US$) in Poland in 2010 to that in 2011?
Your response must be concise. 0.85. What is the ratio of the Imports (BoP, current US$) of Suriname in 2010 to that in 2011?
Offer a terse response. 0.74. What is the ratio of the Imports (BoP, current US$) in Luxembourg in 2010 to that in 2012?
Give a very brief answer. 0.83. What is the ratio of the Imports (BoP, current US$) in Mongolia in 2010 to that in 2012?
Your answer should be compact. 0.48. What is the ratio of the Imports (BoP, current US$) in Poland in 2010 to that in 2012?
Ensure brevity in your answer.  0.9. What is the ratio of the Imports (BoP, current US$) of Suriname in 2010 to that in 2012?
Offer a very short reply. 0.64. What is the ratio of the Imports (BoP, current US$) of Mongolia in 2011 to that in 2012?
Make the answer very short. 0.95. What is the ratio of the Imports (BoP, current US$) of Poland in 2011 to that in 2012?
Make the answer very short. 1.05. What is the ratio of the Imports (BoP, current US$) of Suriname in 2011 to that in 2012?
Give a very brief answer. 0.87. What is the difference between the highest and the second highest Imports (BoP, current US$) in Luxembourg?
Provide a succinct answer. 9.28e+08. What is the difference between the highest and the second highest Imports (BoP, current US$) in Mongolia?
Give a very brief answer. 4.07e+08. What is the difference between the highest and the second highest Imports (BoP, current US$) of Poland?
Offer a very short reply. 4.46e+09. What is the difference between the highest and the second highest Imports (BoP, current US$) in Suriname?
Provide a succinct answer. 3.42e+08. What is the difference between the highest and the lowest Imports (BoP, current US$) in Luxembourg?
Your response must be concise. 2.60e+1. What is the difference between the highest and the lowest Imports (BoP, current US$) in Mongolia?
Make the answer very short. 6.12e+09. What is the difference between the highest and the lowest Imports (BoP, current US$) in Poland?
Make the answer very short. 9.49e+1. What is the difference between the highest and the lowest Imports (BoP, current US$) in Suriname?
Provide a succinct answer. 1.41e+09. 